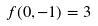<formula> <loc_0><loc_0><loc_500><loc_500>f ( 0 , - 1 ) = 3</formula> 